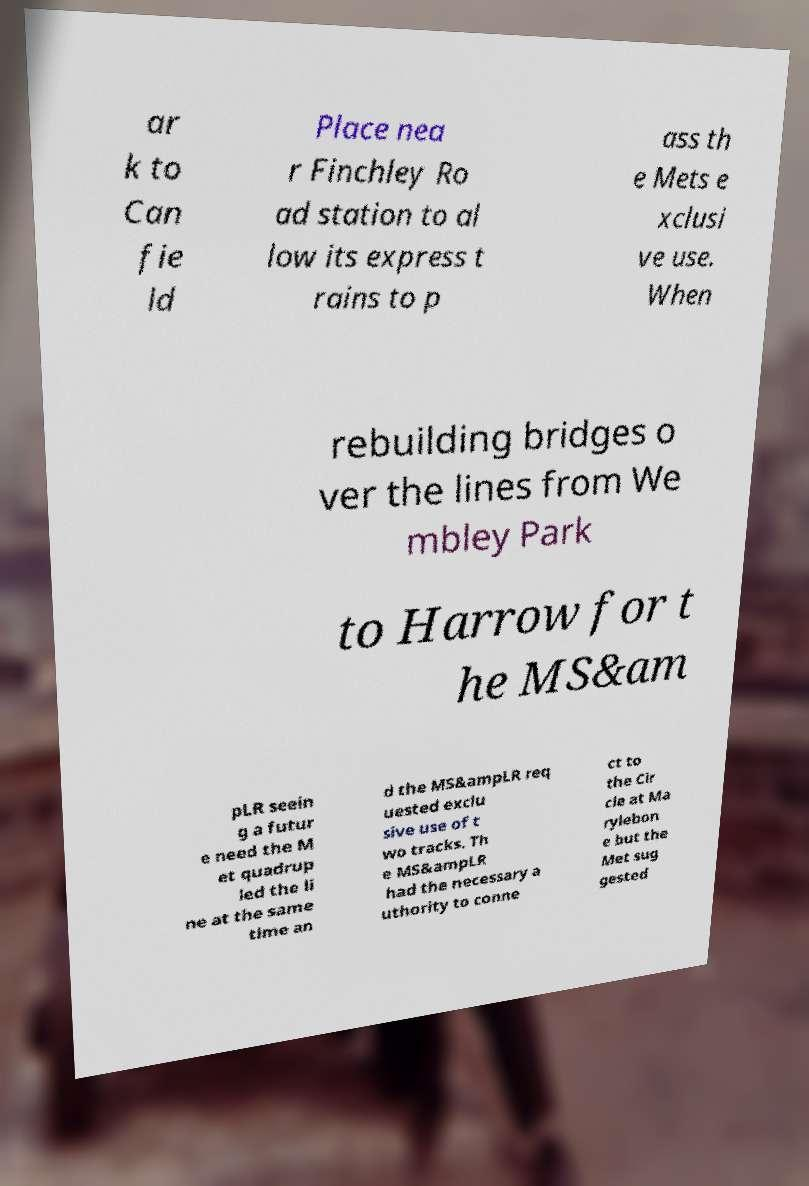Can you accurately transcribe the text from the provided image for me? ar k to Can fie ld Place nea r Finchley Ro ad station to al low its express t rains to p ass th e Mets e xclusi ve use. When rebuilding bridges o ver the lines from We mbley Park to Harrow for t he MS&am pLR seein g a futur e need the M et quadrup led the li ne at the same time an d the MS&ampLR req uested exclu sive use of t wo tracks. Th e MS&ampLR had the necessary a uthority to conne ct to the Cir cle at Ma rylebon e but the Met sug gested 